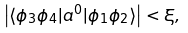<formula> <loc_0><loc_0><loc_500><loc_500>\left | \langle \phi _ { 3 } \phi _ { 4 } | a ^ { 0 } | \phi _ { 1 } \phi _ { 2 } \rangle \right | < \xi ,</formula> 